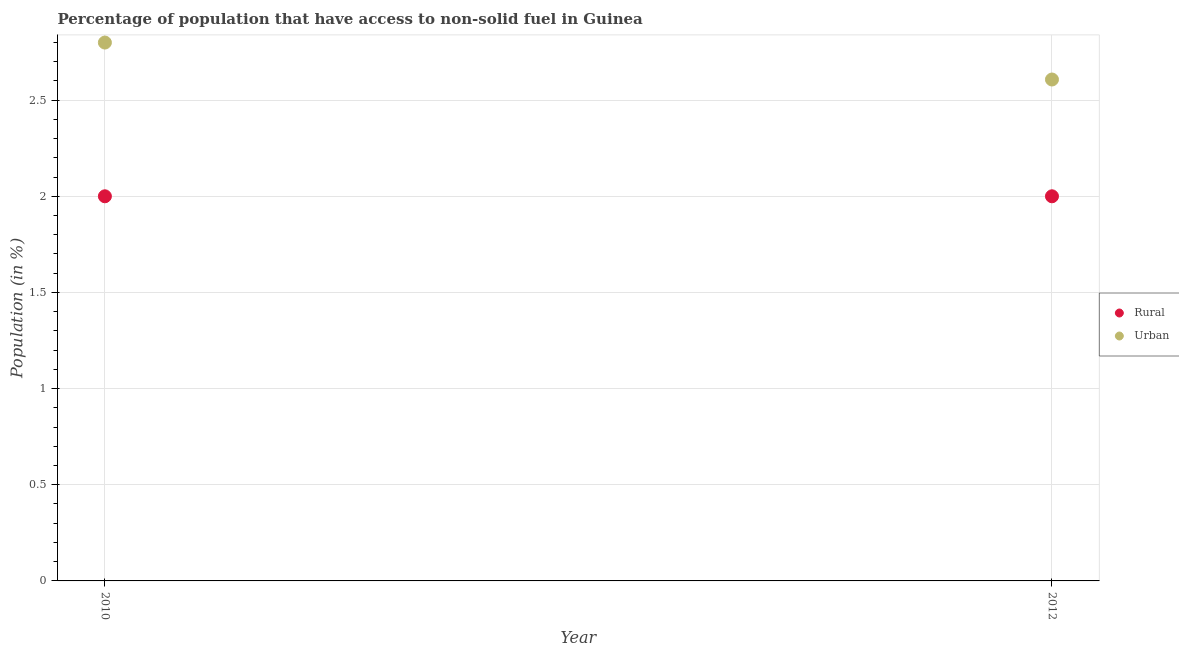Is the number of dotlines equal to the number of legend labels?
Keep it short and to the point. Yes. What is the urban population in 2012?
Provide a succinct answer. 2.61. Across all years, what is the maximum rural population?
Your answer should be very brief. 2. Across all years, what is the minimum rural population?
Your answer should be compact. 2. In which year was the rural population maximum?
Provide a succinct answer. 2010. In which year was the urban population minimum?
Your response must be concise. 2012. What is the total urban population in the graph?
Your answer should be very brief. 5.41. What is the difference between the urban population in 2010 and that in 2012?
Your response must be concise. 0.19. What is the difference between the rural population in 2010 and the urban population in 2012?
Provide a succinct answer. -0.61. What is the average urban population per year?
Your answer should be very brief. 2.7. In the year 2010, what is the difference between the urban population and rural population?
Provide a succinct answer. 0.8. In how many years, is the rural population greater than 0.7 %?
Provide a short and direct response. 2. What is the ratio of the urban population in 2010 to that in 2012?
Offer a terse response. 1.07. Does the urban population monotonically increase over the years?
Your response must be concise. No. What is the difference between two consecutive major ticks on the Y-axis?
Provide a short and direct response. 0.5. Does the graph contain any zero values?
Keep it short and to the point. No. What is the title of the graph?
Your answer should be compact. Percentage of population that have access to non-solid fuel in Guinea. Does "Measles" appear as one of the legend labels in the graph?
Offer a very short reply. No. What is the label or title of the X-axis?
Your answer should be very brief. Year. What is the Population (in %) of Rural in 2010?
Your answer should be very brief. 2. What is the Population (in %) of Urban in 2010?
Provide a succinct answer. 2.8. What is the Population (in %) of Rural in 2012?
Make the answer very short. 2. What is the Population (in %) of Urban in 2012?
Offer a very short reply. 2.61. Across all years, what is the maximum Population (in %) in Rural?
Make the answer very short. 2. Across all years, what is the maximum Population (in %) in Urban?
Ensure brevity in your answer.  2.8. Across all years, what is the minimum Population (in %) of Rural?
Provide a succinct answer. 2. Across all years, what is the minimum Population (in %) of Urban?
Ensure brevity in your answer.  2.61. What is the total Population (in %) of Rural in the graph?
Offer a very short reply. 4. What is the total Population (in %) in Urban in the graph?
Ensure brevity in your answer.  5.41. What is the difference between the Population (in %) of Rural in 2010 and that in 2012?
Offer a very short reply. 0. What is the difference between the Population (in %) in Urban in 2010 and that in 2012?
Provide a succinct answer. 0.19. What is the difference between the Population (in %) in Rural in 2010 and the Population (in %) in Urban in 2012?
Your answer should be very brief. -0.61. What is the average Population (in %) of Rural per year?
Make the answer very short. 2. What is the average Population (in %) of Urban per year?
Your response must be concise. 2.7. In the year 2010, what is the difference between the Population (in %) in Rural and Population (in %) in Urban?
Offer a very short reply. -0.8. In the year 2012, what is the difference between the Population (in %) of Rural and Population (in %) of Urban?
Keep it short and to the point. -0.61. What is the ratio of the Population (in %) of Urban in 2010 to that in 2012?
Your response must be concise. 1.07. What is the difference between the highest and the second highest Population (in %) of Urban?
Make the answer very short. 0.19. What is the difference between the highest and the lowest Population (in %) in Urban?
Your answer should be compact. 0.19. 